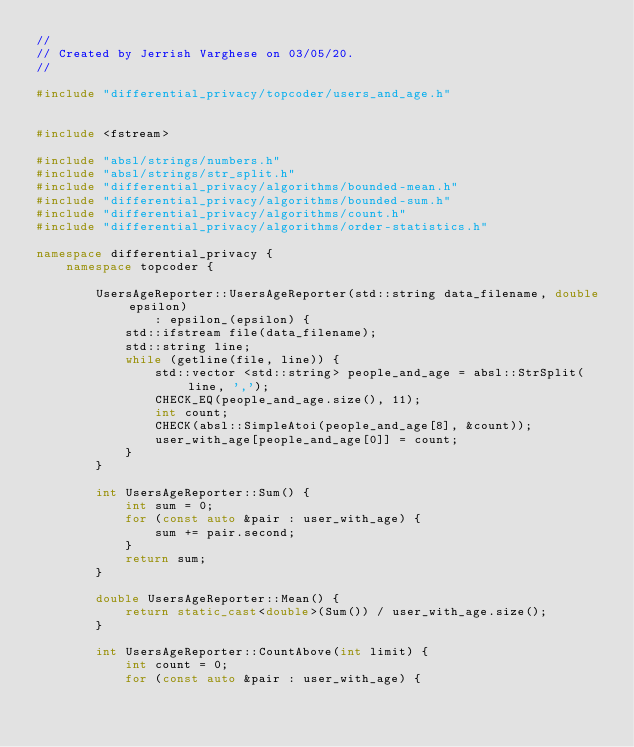Convert code to text. <code><loc_0><loc_0><loc_500><loc_500><_C++_>//
// Created by Jerrish Varghese on 03/05/20.
//

#include "differential_privacy/topcoder/users_and_age.h"


#include <fstream>

#include "absl/strings/numbers.h"
#include "absl/strings/str_split.h"
#include "differential_privacy/algorithms/bounded-mean.h"
#include "differential_privacy/algorithms/bounded-sum.h"
#include "differential_privacy/algorithms/count.h"
#include "differential_privacy/algorithms/order-statistics.h"

namespace differential_privacy {
    namespace topcoder {

        UsersAgeReporter::UsersAgeReporter(std::string data_filename, double epsilon)
                : epsilon_(epsilon) {
            std::ifstream file(data_filename);
            std::string line;
            while (getline(file, line)) {
                std::vector <std::string> people_and_age = absl::StrSplit(line, ',');
                CHECK_EQ(people_and_age.size(), 11);
                int count;
                CHECK(absl::SimpleAtoi(people_and_age[8], &count));
                user_with_age[people_and_age[0]] = count;
            }
        }

        int UsersAgeReporter::Sum() {
            int sum = 0;
            for (const auto &pair : user_with_age) {
                sum += pair.second;
            }
            return sum;
        }

        double UsersAgeReporter::Mean() {
            return static_cast<double>(Sum()) / user_with_age.size();
        }

        int UsersAgeReporter::CountAbove(int limit) {
            int count = 0;
            for (const auto &pair : user_with_age) {</code> 